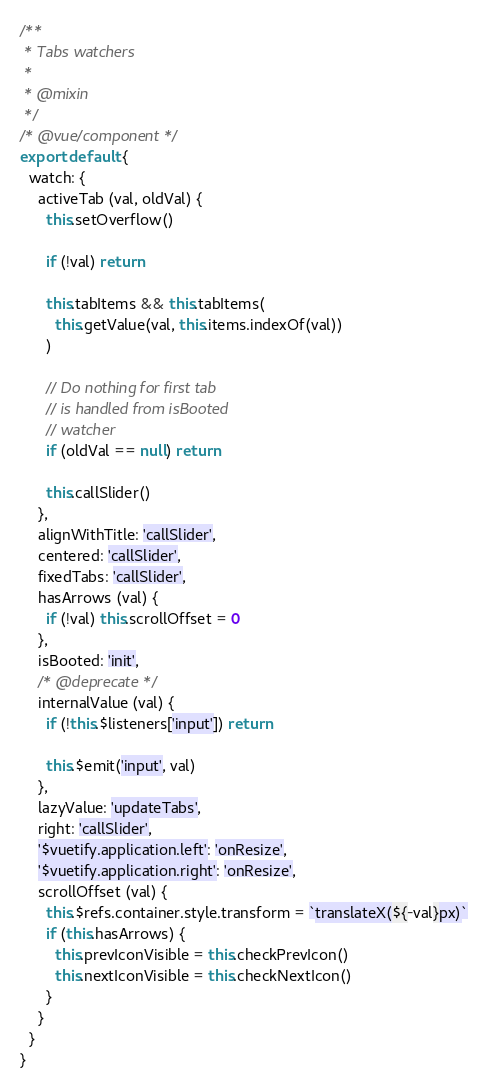Convert code to text. <code><loc_0><loc_0><loc_500><loc_500><_JavaScript_>/**
 * Tabs watchers
 *
 * @mixin
 */
/* @vue/component */
export default {
  watch: {
    activeTab (val, oldVal) {
      this.setOverflow()

      if (!val) return

      this.tabItems && this.tabItems(
        this.getValue(val, this.items.indexOf(val))
      )

      // Do nothing for first tab
      // is handled from isBooted
      // watcher
      if (oldVal == null) return

      this.callSlider()
    },
    alignWithTitle: 'callSlider',
    centered: 'callSlider',
    fixedTabs: 'callSlider',
    hasArrows (val) {
      if (!val) this.scrollOffset = 0
    },
    isBooted: 'init',
    /* @deprecate */
    internalValue (val) {
      if (!this.$listeners['input']) return

      this.$emit('input', val)
    },
    lazyValue: 'updateTabs',
    right: 'callSlider',
    '$vuetify.application.left': 'onResize',
    '$vuetify.application.right': 'onResize',
    scrollOffset (val) {
      this.$refs.container.style.transform = `translateX(${-val}px)`
      if (this.hasArrows) {
        this.prevIconVisible = this.checkPrevIcon()
        this.nextIconVisible = this.checkNextIcon()
      }
    }
  }
}
</code> 